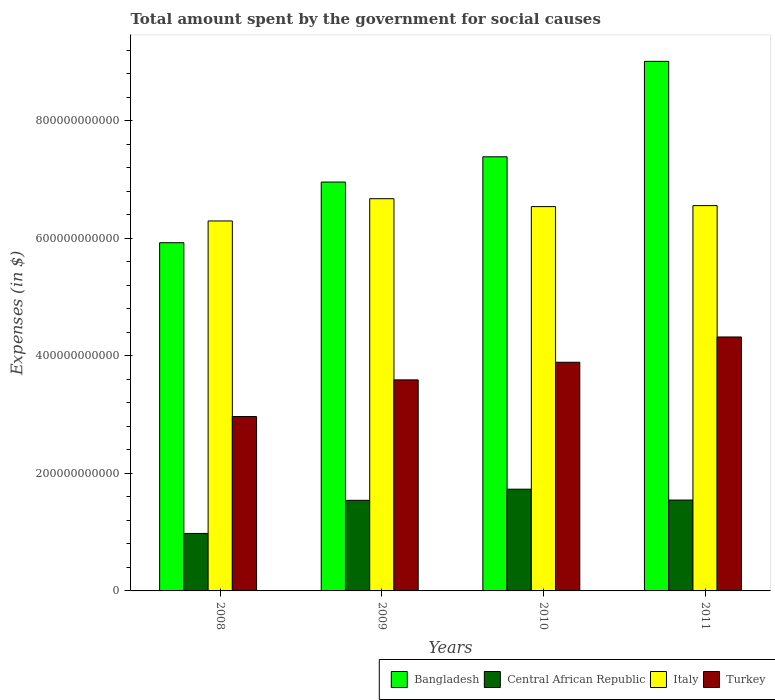How many different coloured bars are there?
Your answer should be compact. 4. How many groups of bars are there?
Provide a short and direct response. 4. Are the number of bars on each tick of the X-axis equal?
Provide a succinct answer. Yes. What is the label of the 2nd group of bars from the left?
Give a very brief answer. 2009. What is the amount spent for social causes by the government in Italy in 2010?
Your answer should be very brief. 6.54e+11. Across all years, what is the maximum amount spent for social causes by the government in Italy?
Keep it short and to the point. 6.68e+11. Across all years, what is the minimum amount spent for social causes by the government in Turkey?
Your response must be concise. 2.97e+11. What is the total amount spent for social causes by the government in Turkey in the graph?
Keep it short and to the point. 1.48e+12. What is the difference between the amount spent for social causes by the government in Bangladesh in 2010 and that in 2011?
Give a very brief answer. -1.62e+11. What is the difference between the amount spent for social causes by the government in Turkey in 2011 and the amount spent for social causes by the government in Central African Republic in 2009?
Provide a short and direct response. 2.78e+11. What is the average amount spent for social causes by the government in Central African Republic per year?
Your answer should be compact. 1.45e+11. In the year 2010, what is the difference between the amount spent for social causes by the government in Bangladesh and amount spent for social causes by the government in Central African Republic?
Make the answer very short. 5.66e+11. What is the ratio of the amount spent for social causes by the government in Central African Republic in 2009 to that in 2011?
Ensure brevity in your answer.  1. What is the difference between the highest and the second highest amount spent for social causes by the government in Turkey?
Give a very brief answer. 4.30e+1. What is the difference between the highest and the lowest amount spent for social causes by the government in Italy?
Your response must be concise. 3.79e+1. In how many years, is the amount spent for social causes by the government in Bangladesh greater than the average amount spent for social causes by the government in Bangladesh taken over all years?
Provide a short and direct response. 2. What does the 2nd bar from the left in 2011 represents?
Your response must be concise. Central African Republic. What does the 3rd bar from the right in 2010 represents?
Provide a short and direct response. Central African Republic. Is it the case that in every year, the sum of the amount spent for social causes by the government in Turkey and amount spent for social causes by the government in Central African Republic is greater than the amount spent for social causes by the government in Bangladesh?
Your response must be concise. No. Are all the bars in the graph horizontal?
Your answer should be very brief. No. How many years are there in the graph?
Your response must be concise. 4. What is the difference between two consecutive major ticks on the Y-axis?
Your answer should be very brief. 2.00e+11. How many legend labels are there?
Provide a succinct answer. 4. What is the title of the graph?
Ensure brevity in your answer.  Total amount spent by the government for social causes. What is the label or title of the Y-axis?
Your response must be concise. Expenses (in $). What is the Expenses (in $) in Bangladesh in 2008?
Make the answer very short. 5.93e+11. What is the Expenses (in $) of Central African Republic in 2008?
Offer a terse response. 9.79e+1. What is the Expenses (in $) in Italy in 2008?
Provide a succinct answer. 6.30e+11. What is the Expenses (in $) of Turkey in 2008?
Your answer should be compact. 2.97e+11. What is the Expenses (in $) in Bangladesh in 2009?
Ensure brevity in your answer.  6.96e+11. What is the Expenses (in $) in Central African Republic in 2009?
Offer a terse response. 1.54e+11. What is the Expenses (in $) in Italy in 2009?
Ensure brevity in your answer.  6.68e+11. What is the Expenses (in $) in Turkey in 2009?
Provide a succinct answer. 3.59e+11. What is the Expenses (in $) of Bangladesh in 2010?
Your answer should be compact. 7.39e+11. What is the Expenses (in $) in Central African Republic in 2010?
Provide a short and direct response. 1.73e+11. What is the Expenses (in $) in Italy in 2010?
Make the answer very short. 6.54e+11. What is the Expenses (in $) of Turkey in 2010?
Keep it short and to the point. 3.89e+11. What is the Expenses (in $) of Bangladesh in 2011?
Offer a terse response. 9.01e+11. What is the Expenses (in $) of Central African Republic in 2011?
Offer a terse response. 1.55e+11. What is the Expenses (in $) of Italy in 2011?
Your answer should be compact. 6.56e+11. What is the Expenses (in $) in Turkey in 2011?
Keep it short and to the point. 4.32e+11. Across all years, what is the maximum Expenses (in $) in Bangladesh?
Provide a succinct answer. 9.01e+11. Across all years, what is the maximum Expenses (in $) in Central African Republic?
Make the answer very short. 1.73e+11. Across all years, what is the maximum Expenses (in $) of Italy?
Provide a succinct answer. 6.68e+11. Across all years, what is the maximum Expenses (in $) in Turkey?
Your response must be concise. 4.32e+11. Across all years, what is the minimum Expenses (in $) in Bangladesh?
Provide a short and direct response. 5.93e+11. Across all years, what is the minimum Expenses (in $) in Central African Republic?
Make the answer very short. 9.79e+1. Across all years, what is the minimum Expenses (in $) in Italy?
Your answer should be very brief. 6.30e+11. Across all years, what is the minimum Expenses (in $) of Turkey?
Offer a terse response. 2.97e+11. What is the total Expenses (in $) of Bangladesh in the graph?
Your response must be concise. 2.93e+12. What is the total Expenses (in $) in Central African Republic in the graph?
Give a very brief answer. 5.80e+11. What is the total Expenses (in $) in Italy in the graph?
Your response must be concise. 2.61e+12. What is the total Expenses (in $) in Turkey in the graph?
Provide a short and direct response. 1.48e+12. What is the difference between the Expenses (in $) of Bangladesh in 2008 and that in 2009?
Provide a succinct answer. -1.03e+11. What is the difference between the Expenses (in $) of Central African Republic in 2008 and that in 2009?
Make the answer very short. -5.64e+1. What is the difference between the Expenses (in $) in Italy in 2008 and that in 2009?
Offer a terse response. -3.79e+1. What is the difference between the Expenses (in $) of Turkey in 2008 and that in 2009?
Provide a succinct answer. -6.24e+1. What is the difference between the Expenses (in $) in Bangladesh in 2008 and that in 2010?
Provide a short and direct response. -1.46e+11. What is the difference between the Expenses (in $) of Central African Republic in 2008 and that in 2010?
Give a very brief answer. -7.53e+1. What is the difference between the Expenses (in $) of Italy in 2008 and that in 2010?
Your response must be concise. -2.44e+1. What is the difference between the Expenses (in $) in Turkey in 2008 and that in 2010?
Make the answer very short. -9.24e+1. What is the difference between the Expenses (in $) of Bangladesh in 2008 and that in 2011?
Offer a terse response. -3.09e+11. What is the difference between the Expenses (in $) in Central African Republic in 2008 and that in 2011?
Provide a succinct answer. -5.68e+1. What is the difference between the Expenses (in $) of Italy in 2008 and that in 2011?
Offer a very short reply. -2.61e+1. What is the difference between the Expenses (in $) of Turkey in 2008 and that in 2011?
Offer a very short reply. -1.35e+11. What is the difference between the Expenses (in $) of Bangladesh in 2009 and that in 2010?
Your response must be concise. -4.30e+1. What is the difference between the Expenses (in $) in Central African Republic in 2009 and that in 2010?
Provide a succinct answer. -1.89e+1. What is the difference between the Expenses (in $) of Italy in 2009 and that in 2010?
Offer a terse response. 1.35e+1. What is the difference between the Expenses (in $) in Turkey in 2009 and that in 2010?
Offer a terse response. -3.00e+1. What is the difference between the Expenses (in $) in Bangladesh in 2009 and that in 2011?
Your answer should be compact. -2.05e+11. What is the difference between the Expenses (in $) in Central African Republic in 2009 and that in 2011?
Your answer should be compact. -4.45e+08. What is the difference between the Expenses (in $) in Italy in 2009 and that in 2011?
Provide a succinct answer. 1.18e+1. What is the difference between the Expenses (in $) in Turkey in 2009 and that in 2011?
Your answer should be compact. -7.30e+1. What is the difference between the Expenses (in $) of Bangladesh in 2010 and that in 2011?
Offer a very short reply. -1.62e+11. What is the difference between the Expenses (in $) of Central African Republic in 2010 and that in 2011?
Your answer should be compact. 1.85e+1. What is the difference between the Expenses (in $) in Italy in 2010 and that in 2011?
Make the answer very short. -1.66e+09. What is the difference between the Expenses (in $) in Turkey in 2010 and that in 2011?
Offer a very short reply. -4.30e+1. What is the difference between the Expenses (in $) in Bangladesh in 2008 and the Expenses (in $) in Central African Republic in 2009?
Provide a short and direct response. 4.39e+11. What is the difference between the Expenses (in $) of Bangladesh in 2008 and the Expenses (in $) of Italy in 2009?
Provide a short and direct response. -7.49e+1. What is the difference between the Expenses (in $) in Bangladesh in 2008 and the Expenses (in $) in Turkey in 2009?
Your answer should be very brief. 2.34e+11. What is the difference between the Expenses (in $) of Central African Republic in 2008 and the Expenses (in $) of Italy in 2009?
Your response must be concise. -5.70e+11. What is the difference between the Expenses (in $) in Central African Republic in 2008 and the Expenses (in $) in Turkey in 2009?
Provide a short and direct response. -2.61e+11. What is the difference between the Expenses (in $) of Italy in 2008 and the Expenses (in $) of Turkey in 2009?
Your response must be concise. 2.71e+11. What is the difference between the Expenses (in $) of Bangladesh in 2008 and the Expenses (in $) of Central African Republic in 2010?
Give a very brief answer. 4.20e+11. What is the difference between the Expenses (in $) of Bangladesh in 2008 and the Expenses (in $) of Italy in 2010?
Offer a terse response. -6.15e+1. What is the difference between the Expenses (in $) in Bangladesh in 2008 and the Expenses (in $) in Turkey in 2010?
Offer a very short reply. 2.04e+11. What is the difference between the Expenses (in $) of Central African Republic in 2008 and the Expenses (in $) of Italy in 2010?
Your answer should be very brief. -5.56e+11. What is the difference between the Expenses (in $) of Central African Republic in 2008 and the Expenses (in $) of Turkey in 2010?
Provide a succinct answer. -2.91e+11. What is the difference between the Expenses (in $) in Italy in 2008 and the Expenses (in $) in Turkey in 2010?
Provide a short and direct response. 2.41e+11. What is the difference between the Expenses (in $) in Bangladesh in 2008 and the Expenses (in $) in Central African Republic in 2011?
Provide a short and direct response. 4.38e+11. What is the difference between the Expenses (in $) of Bangladesh in 2008 and the Expenses (in $) of Italy in 2011?
Give a very brief answer. -6.31e+1. What is the difference between the Expenses (in $) in Bangladesh in 2008 and the Expenses (in $) in Turkey in 2011?
Keep it short and to the point. 1.60e+11. What is the difference between the Expenses (in $) of Central African Republic in 2008 and the Expenses (in $) of Italy in 2011?
Your response must be concise. -5.58e+11. What is the difference between the Expenses (in $) in Central African Republic in 2008 and the Expenses (in $) in Turkey in 2011?
Give a very brief answer. -3.34e+11. What is the difference between the Expenses (in $) of Italy in 2008 and the Expenses (in $) of Turkey in 2011?
Your answer should be compact. 1.98e+11. What is the difference between the Expenses (in $) of Bangladesh in 2009 and the Expenses (in $) of Central African Republic in 2010?
Offer a terse response. 5.23e+11. What is the difference between the Expenses (in $) of Bangladesh in 2009 and the Expenses (in $) of Italy in 2010?
Your response must be concise. 4.18e+1. What is the difference between the Expenses (in $) of Bangladesh in 2009 and the Expenses (in $) of Turkey in 2010?
Your response must be concise. 3.07e+11. What is the difference between the Expenses (in $) in Central African Republic in 2009 and the Expenses (in $) in Italy in 2010?
Provide a short and direct response. -5.00e+11. What is the difference between the Expenses (in $) of Central African Republic in 2009 and the Expenses (in $) of Turkey in 2010?
Ensure brevity in your answer.  -2.35e+11. What is the difference between the Expenses (in $) of Italy in 2009 and the Expenses (in $) of Turkey in 2010?
Give a very brief answer. 2.78e+11. What is the difference between the Expenses (in $) in Bangladesh in 2009 and the Expenses (in $) in Central African Republic in 2011?
Your response must be concise. 5.41e+11. What is the difference between the Expenses (in $) of Bangladesh in 2009 and the Expenses (in $) of Italy in 2011?
Provide a succinct answer. 4.01e+1. What is the difference between the Expenses (in $) in Bangladesh in 2009 and the Expenses (in $) in Turkey in 2011?
Ensure brevity in your answer.  2.64e+11. What is the difference between the Expenses (in $) of Central African Republic in 2009 and the Expenses (in $) of Italy in 2011?
Make the answer very short. -5.02e+11. What is the difference between the Expenses (in $) of Central African Republic in 2009 and the Expenses (in $) of Turkey in 2011?
Offer a terse response. -2.78e+11. What is the difference between the Expenses (in $) of Italy in 2009 and the Expenses (in $) of Turkey in 2011?
Give a very brief answer. 2.35e+11. What is the difference between the Expenses (in $) of Bangladesh in 2010 and the Expenses (in $) of Central African Republic in 2011?
Provide a succinct answer. 5.84e+11. What is the difference between the Expenses (in $) in Bangladesh in 2010 and the Expenses (in $) in Italy in 2011?
Keep it short and to the point. 8.31e+1. What is the difference between the Expenses (in $) of Bangladesh in 2010 and the Expenses (in $) of Turkey in 2011?
Your answer should be very brief. 3.07e+11. What is the difference between the Expenses (in $) of Central African Republic in 2010 and the Expenses (in $) of Italy in 2011?
Provide a short and direct response. -4.83e+11. What is the difference between the Expenses (in $) of Central African Republic in 2010 and the Expenses (in $) of Turkey in 2011?
Offer a very short reply. -2.59e+11. What is the difference between the Expenses (in $) in Italy in 2010 and the Expenses (in $) in Turkey in 2011?
Keep it short and to the point. 2.22e+11. What is the average Expenses (in $) of Bangladesh per year?
Offer a very short reply. 7.32e+11. What is the average Expenses (in $) of Central African Republic per year?
Your answer should be compact. 1.45e+11. What is the average Expenses (in $) in Italy per year?
Make the answer very short. 6.52e+11. What is the average Expenses (in $) in Turkey per year?
Give a very brief answer. 3.69e+11. In the year 2008, what is the difference between the Expenses (in $) in Bangladesh and Expenses (in $) in Central African Republic?
Ensure brevity in your answer.  4.95e+11. In the year 2008, what is the difference between the Expenses (in $) of Bangladesh and Expenses (in $) of Italy?
Provide a short and direct response. -3.70e+1. In the year 2008, what is the difference between the Expenses (in $) in Bangladesh and Expenses (in $) in Turkey?
Keep it short and to the point. 2.96e+11. In the year 2008, what is the difference between the Expenses (in $) in Central African Republic and Expenses (in $) in Italy?
Keep it short and to the point. -5.32e+11. In the year 2008, what is the difference between the Expenses (in $) in Central African Republic and Expenses (in $) in Turkey?
Offer a very short reply. -1.99e+11. In the year 2008, what is the difference between the Expenses (in $) of Italy and Expenses (in $) of Turkey?
Your answer should be compact. 3.33e+11. In the year 2009, what is the difference between the Expenses (in $) in Bangladesh and Expenses (in $) in Central African Republic?
Provide a succinct answer. 5.42e+11. In the year 2009, what is the difference between the Expenses (in $) in Bangladesh and Expenses (in $) in Italy?
Keep it short and to the point. 2.83e+1. In the year 2009, what is the difference between the Expenses (in $) in Bangladesh and Expenses (in $) in Turkey?
Your response must be concise. 3.37e+11. In the year 2009, what is the difference between the Expenses (in $) in Central African Republic and Expenses (in $) in Italy?
Provide a succinct answer. -5.13e+11. In the year 2009, what is the difference between the Expenses (in $) of Central African Republic and Expenses (in $) of Turkey?
Offer a very short reply. -2.05e+11. In the year 2009, what is the difference between the Expenses (in $) of Italy and Expenses (in $) of Turkey?
Provide a short and direct response. 3.08e+11. In the year 2010, what is the difference between the Expenses (in $) in Bangladesh and Expenses (in $) in Central African Republic?
Give a very brief answer. 5.66e+11. In the year 2010, what is the difference between the Expenses (in $) in Bangladesh and Expenses (in $) in Italy?
Provide a short and direct response. 8.48e+1. In the year 2010, what is the difference between the Expenses (in $) of Bangladesh and Expenses (in $) of Turkey?
Your response must be concise. 3.50e+11. In the year 2010, what is the difference between the Expenses (in $) in Central African Republic and Expenses (in $) in Italy?
Provide a short and direct response. -4.81e+11. In the year 2010, what is the difference between the Expenses (in $) of Central African Republic and Expenses (in $) of Turkey?
Make the answer very short. -2.16e+11. In the year 2010, what is the difference between the Expenses (in $) in Italy and Expenses (in $) in Turkey?
Your answer should be very brief. 2.65e+11. In the year 2011, what is the difference between the Expenses (in $) of Bangladesh and Expenses (in $) of Central African Republic?
Your response must be concise. 7.47e+11. In the year 2011, what is the difference between the Expenses (in $) in Bangladesh and Expenses (in $) in Italy?
Provide a succinct answer. 2.46e+11. In the year 2011, what is the difference between the Expenses (in $) in Bangladesh and Expenses (in $) in Turkey?
Offer a terse response. 4.69e+11. In the year 2011, what is the difference between the Expenses (in $) in Central African Republic and Expenses (in $) in Italy?
Give a very brief answer. -5.01e+11. In the year 2011, what is the difference between the Expenses (in $) in Central African Republic and Expenses (in $) in Turkey?
Your answer should be compact. -2.78e+11. In the year 2011, what is the difference between the Expenses (in $) in Italy and Expenses (in $) in Turkey?
Offer a terse response. 2.24e+11. What is the ratio of the Expenses (in $) in Bangladesh in 2008 to that in 2009?
Ensure brevity in your answer.  0.85. What is the ratio of the Expenses (in $) in Central African Republic in 2008 to that in 2009?
Offer a terse response. 0.63. What is the ratio of the Expenses (in $) of Italy in 2008 to that in 2009?
Offer a terse response. 0.94. What is the ratio of the Expenses (in $) of Turkey in 2008 to that in 2009?
Provide a short and direct response. 0.83. What is the ratio of the Expenses (in $) in Bangladesh in 2008 to that in 2010?
Your answer should be compact. 0.8. What is the ratio of the Expenses (in $) in Central African Republic in 2008 to that in 2010?
Give a very brief answer. 0.56. What is the ratio of the Expenses (in $) in Italy in 2008 to that in 2010?
Provide a short and direct response. 0.96. What is the ratio of the Expenses (in $) in Turkey in 2008 to that in 2010?
Make the answer very short. 0.76. What is the ratio of the Expenses (in $) of Bangladesh in 2008 to that in 2011?
Offer a terse response. 0.66. What is the ratio of the Expenses (in $) in Central African Republic in 2008 to that in 2011?
Your answer should be compact. 0.63. What is the ratio of the Expenses (in $) of Italy in 2008 to that in 2011?
Offer a very short reply. 0.96. What is the ratio of the Expenses (in $) of Turkey in 2008 to that in 2011?
Offer a very short reply. 0.69. What is the ratio of the Expenses (in $) in Bangladesh in 2009 to that in 2010?
Offer a very short reply. 0.94. What is the ratio of the Expenses (in $) of Central African Republic in 2009 to that in 2010?
Offer a terse response. 0.89. What is the ratio of the Expenses (in $) in Italy in 2009 to that in 2010?
Offer a very short reply. 1.02. What is the ratio of the Expenses (in $) of Turkey in 2009 to that in 2010?
Make the answer very short. 0.92. What is the ratio of the Expenses (in $) of Bangladesh in 2009 to that in 2011?
Offer a very short reply. 0.77. What is the ratio of the Expenses (in $) of Central African Republic in 2009 to that in 2011?
Ensure brevity in your answer.  1. What is the ratio of the Expenses (in $) of Turkey in 2009 to that in 2011?
Give a very brief answer. 0.83. What is the ratio of the Expenses (in $) in Bangladesh in 2010 to that in 2011?
Give a very brief answer. 0.82. What is the ratio of the Expenses (in $) in Central African Republic in 2010 to that in 2011?
Provide a succinct answer. 1.12. What is the ratio of the Expenses (in $) in Turkey in 2010 to that in 2011?
Ensure brevity in your answer.  0.9. What is the difference between the highest and the second highest Expenses (in $) of Bangladesh?
Offer a very short reply. 1.62e+11. What is the difference between the highest and the second highest Expenses (in $) in Central African Republic?
Your answer should be compact. 1.85e+1. What is the difference between the highest and the second highest Expenses (in $) in Italy?
Give a very brief answer. 1.18e+1. What is the difference between the highest and the second highest Expenses (in $) of Turkey?
Offer a terse response. 4.30e+1. What is the difference between the highest and the lowest Expenses (in $) of Bangladesh?
Your answer should be compact. 3.09e+11. What is the difference between the highest and the lowest Expenses (in $) of Central African Republic?
Offer a very short reply. 7.53e+1. What is the difference between the highest and the lowest Expenses (in $) in Italy?
Provide a short and direct response. 3.79e+1. What is the difference between the highest and the lowest Expenses (in $) in Turkey?
Provide a short and direct response. 1.35e+11. 